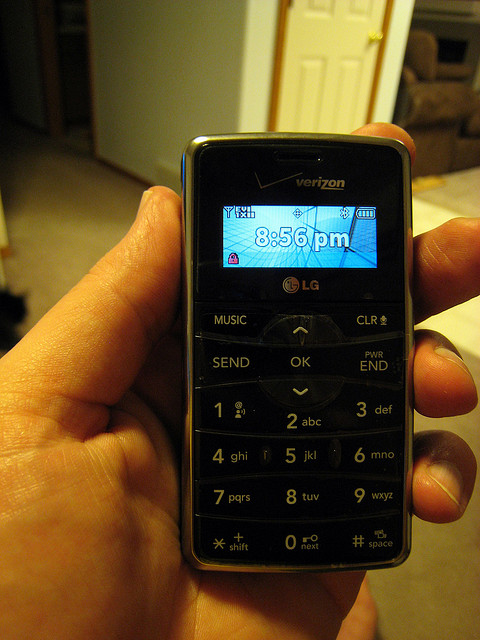<image>What is on the man's wrist? I don't know what is on the man's wrist. It could be a watch or nothing. What is on the man's wrist? I am not sure what is on the man's wrist. It can be seen a watch or nothing. 